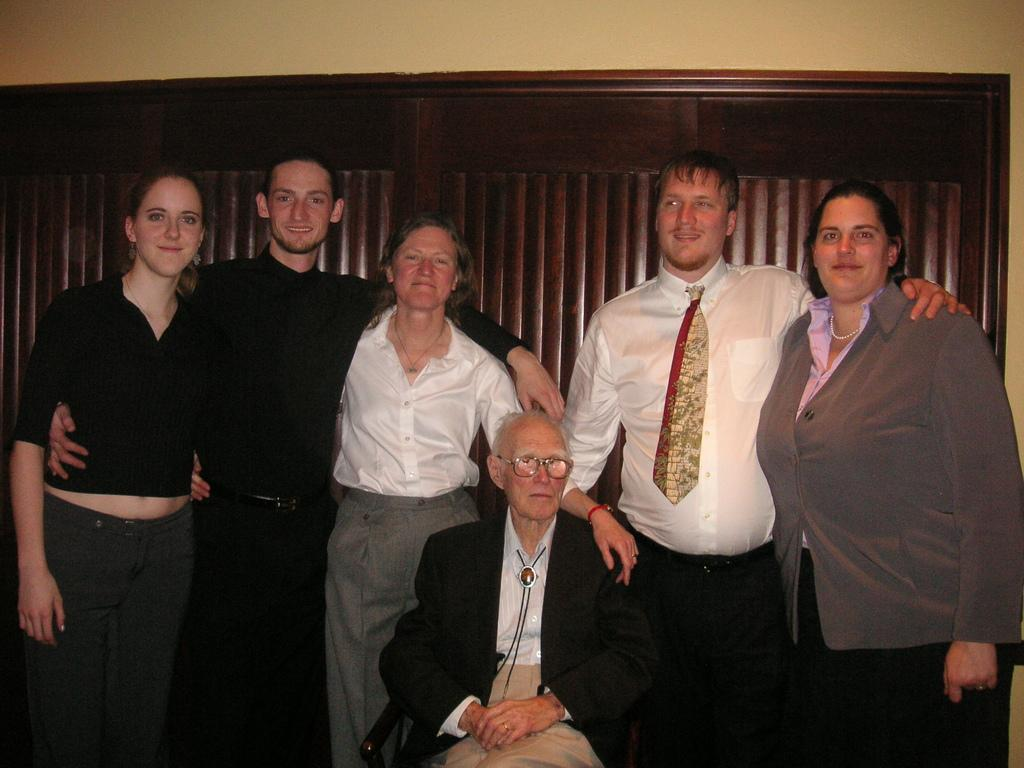How many people are in the image? There is a group of people in the image. What is the position of one of the men in the image? One man is sitting in the image. What are the other people in the image doing? Other people are standing in the image. What can be seen in the background of the image? There is a wall in the background of the image, and there are other unspecified elements as well. What type of card is being used to make a discovery in the image? There is no card or discovery present in the image; it features a group of people with one man sitting and others standing. 